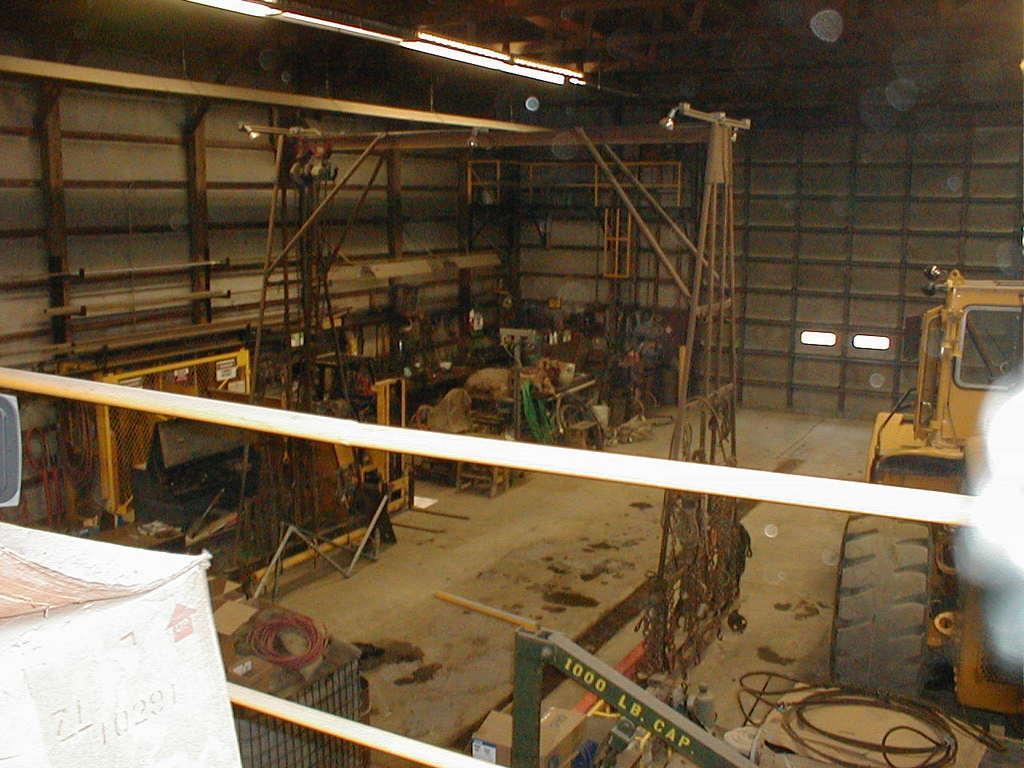In one or two sentences, can you explain what this image depicts? This image is taken inside a garage. There are metal rods. There are machines. At the top of the image there is ceiling with lights. To the right side of the image there is a vehicle. 